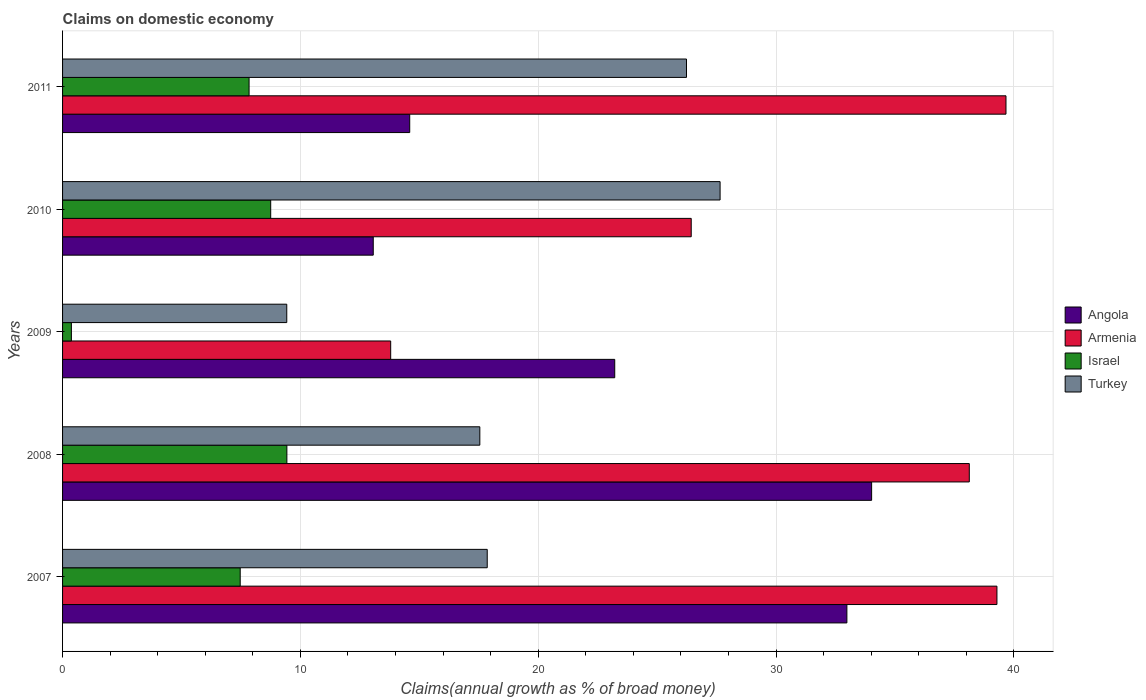How many different coloured bars are there?
Keep it short and to the point. 4. How many groups of bars are there?
Keep it short and to the point. 5. Are the number of bars per tick equal to the number of legend labels?
Your response must be concise. Yes. How many bars are there on the 2nd tick from the top?
Your response must be concise. 4. How many bars are there on the 3rd tick from the bottom?
Provide a short and direct response. 4. What is the label of the 5th group of bars from the top?
Your answer should be very brief. 2007. In how many cases, is the number of bars for a given year not equal to the number of legend labels?
Keep it short and to the point. 0. What is the percentage of broad money claimed on domestic economy in Israel in 2011?
Ensure brevity in your answer.  7.84. Across all years, what is the maximum percentage of broad money claimed on domestic economy in Turkey?
Give a very brief answer. 27.65. Across all years, what is the minimum percentage of broad money claimed on domestic economy in Israel?
Your response must be concise. 0.37. In which year was the percentage of broad money claimed on domestic economy in Angola minimum?
Give a very brief answer. 2010. What is the total percentage of broad money claimed on domestic economy in Armenia in the graph?
Provide a succinct answer. 157.31. What is the difference between the percentage of broad money claimed on domestic economy in Angola in 2007 and that in 2009?
Your answer should be very brief. 9.76. What is the difference between the percentage of broad money claimed on domestic economy in Armenia in 2009 and the percentage of broad money claimed on domestic economy in Israel in 2008?
Your answer should be very brief. 4.37. What is the average percentage of broad money claimed on domestic economy in Angola per year?
Provide a succinct answer. 23.57. In the year 2009, what is the difference between the percentage of broad money claimed on domestic economy in Angola and percentage of broad money claimed on domestic economy in Israel?
Your response must be concise. 22.85. In how many years, is the percentage of broad money claimed on domestic economy in Armenia greater than 38 %?
Your answer should be very brief. 3. What is the ratio of the percentage of broad money claimed on domestic economy in Israel in 2009 to that in 2010?
Provide a short and direct response. 0.04. Is the difference between the percentage of broad money claimed on domestic economy in Angola in 2007 and 2008 greater than the difference between the percentage of broad money claimed on domestic economy in Israel in 2007 and 2008?
Give a very brief answer. Yes. What is the difference between the highest and the second highest percentage of broad money claimed on domestic economy in Turkey?
Your response must be concise. 1.41. What is the difference between the highest and the lowest percentage of broad money claimed on domestic economy in Turkey?
Offer a very short reply. 18.22. Is the sum of the percentage of broad money claimed on domestic economy in Turkey in 2007 and 2008 greater than the maximum percentage of broad money claimed on domestic economy in Armenia across all years?
Give a very brief answer. No. Is it the case that in every year, the sum of the percentage of broad money claimed on domestic economy in Israel and percentage of broad money claimed on domestic economy in Angola is greater than the sum of percentage of broad money claimed on domestic economy in Turkey and percentage of broad money claimed on domestic economy in Armenia?
Offer a terse response. Yes. What does the 4th bar from the top in 2011 represents?
Provide a short and direct response. Angola. What does the 3rd bar from the bottom in 2011 represents?
Give a very brief answer. Israel. Is it the case that in every year, the sum of the percentage of broad money claimed on domestic economy in Turkey and percentage of broad money claimed on domestic economy in Israel is greater than the percentage of broad money claimed on domestic economy in Armenia?
Offer a very short reply. No. How many years are there in the graph?
Ensure brevity in your answer.  5. What is the difference between two consecutive major ticks on the X-axis?
Provide a short and direct response. 10. Does the graph contain grids?
Provide a succinct answer. Yes. What is the title of the graph?
Your response must be concise. Claims on domestic economy. What is the label or title of the X-axis?
Make the answer very short. Claims(annual growth as % of broad money). What is the Claims(annual growth as % of broad money) in Angola in 2007?
Give a very brief answer. 32.98. What is the Claims(annual growth as % of broad money) in Armenia in 2007?
Your answer should be very brief. 39.29. What is the Claims(annual growth as % of broad money) of Israel in 2007?
Provide a succinct answer. 7.47. What is the Claims(annual growth as % of broad money) in Turkey in 2007?
Keep it short and to the point. 17.86. What is the Claims(annual growth as % of broad money) of Angola in 2008?
Your response must be concise. 34.02. What is the Claims(annual growth as % of broad money) in Armenia in 2008?
Offer a terse response. 38.12. What is the Claims(annual growth as % of broad money) of Israel in 2008?
Make the answer very short. 9.43. What is the Claims(annual growth as % of broad money) of Turkey in 2008?
Offer a very short reply. 17.54. What is the Claims(annual growth as % of broad money) in Angola in 2009?
Your response must be concise. 23.22. What is the Claims(annual growth as % of broad money) of Armenia in 2009?
Offer a terse response. 13.8. What is the Claims(annual growth as % of broad money) in Israel in 2009?
Give a very brief answer. 0.37. What is the Claims(annual growth as % of broad money) of Turkey in 2009?
Provide a short and direct response. 9.43. What is the Claims(annual growth as % of broad money) in Angola in 2010?
Provide a succinct answer. 13.06. What is the Claims(annual growth as % of broad money) of Armenia in 2010?
Your answer should be compact. 26.43. What is the Claims(annual growth as % of broad money) of Israel in 2010?
Offer a terse response. 8.75. What is the Claims(annual growth as % of broad money) in Turkey in 2010?
Ensure brevity in your answer.  27.65. What is the Claims(annual growth as % of broad money) of Angola in 2011?
Give a very brief answer. 14.6. What is the Claims(annual growth as % of broad money) of Armenia in 2011?
Offer a terse response. 39.67. What is the Claims(annual growth as % of broad money) of Israel in 2011?
Make the answer very short. 7.84. What is the Claims(annual growth as % of broad money) in Turkey in 2011?
Offer a terse response. 26.23. Across all years, what is the maximum Claims(annual growth as % of broad money) of Angola?
Provide a short and direct response. 34.02. Across all years, what is the maximum Claims(annual growth as % of broad money) in Armenia?
Your answer should be very brief. 39.67. Across all years, what is the maximum Claims(annual growth as % of broad money) of Israel?
Offer a very short reply. 9.43. Across all years, what is the maximum Claims(annual growth as % of broad money) in Turkey?
Your response must be concise. 27.65. Across all years, what is the minimum Claims(annual growth as % of broad money) of Angola?
Give a very brief answer. 13.06. Across all years, what is the minimum Claims(annual growth as % of broad money) in Armenia?
Provide a short and direct response. 13.8. Across all years, what is the minimum Claims(annual growth as % of broad money) in Israel?
Your answer should be compact. 0.37. Across all years, what is the minimum Claims(annual growth as % of broad money) of Turkey?
Offer a terse response. 9.43. What is the total Claims(annual growth as % of broad money) in Angola in the graph?
Provide a succinct answer. 117.87. What is the total Claims(annual growth as % of broad money) in Armenia in the graph?
Offer a very short reply. 157.31. What is the total Claims(annual growth as % of broad money) of Israel in the graph?
Your answer should be very brief. 33.86. What is the total Claims(annual growth as % of broad money) in Turkey in the graph?
Give a very brief answer. 98.71. What is the difference between the Claims(annual growth as % of broad money) of Angola in 2007 and that in 2008?
Ensure brevity in your answer.  -1.04. What is the difference between the Claims(annual growth as % of broad money) of Armenia in 2007 and that in 2008?
Provide a short and direct response. 1.16. What is the difference between the Claims(annual growth as % of broad money) of Israel in 2007 and that in 2008?
Offer a very short reply. -1.96. What is the difference between the Claims(annual growth as % of broad money) in Turkey in 2007 and that in 2008?
Keep it short and to the point. 0.31. What is the difference between the Claims(annual growth as % of broad money) in Angola in 2007 and that in 2009?
Offer a very short reply. 9.76. What is the difference between the Claims(annual growth as % of broad money) in Armenia in 2007 and that in 2009?
Give a very brief answer. 25.49. What is the difference between the Claims(annual growth as % of broad money) in Israel in 2007 and that in 2009?
Give a very brief answer. 7.1. What is the difference between the Claims(annual growth as % of broad money) in Turkey in 2007 and that in 2009?
Make the answer very short. 8.43. What is the difference between the Claims(annual growth as % of broad money) in Angola in 2007 and that in 2010?
Give a very brief answer. 19.91. What is the difference between the Claims(annual growth as % of broad money) in Armenia in 2007 and that in 2010?
Ensure brevity in your answer.  12.85. What is the difference between the Claims(annual growth as % of broad money) of Israel in 2007 and that in 2010?
Provide a succinct answer. -1.28. What is the difference between the Claims(annual growth as % of broad money) of Turkey in 2007 and that in 2010?
Make the answer very short. -9.79. What is the difference between the Claims(annual growth as % of broad money) of Angola in 2007 and that in 2011?
Provide a succinct answer. 18.38. What is the difference between the Claims(annual growth as % of broad money) in Armenia in 2007 and that in 2011?
Provide a succinct answer. -0.38. What is the difference between the Claims(annual growth as % of broad money) of Israel in 2007 and that in 2011?
Make the answer very short. -0.37. What is the difference between the Claims(annual growth as % of broad money) in Turkey in 2007 and that in 2011?
Provide a short and direct response. -8.38. What is the difference between the Claims(annual growth as % of broad money) of Angola in 2008 and that in 2009?
Your answer should be compact. 10.8. What is the difference between the Claims(annual growth as % of broad money) of Armenia in 2008 and that in 2009?
Your answer should be compact. 24.33. What is the difference between the Claims(annual growth as % of broad money) in Israel in 2008 and that in 2009?
Provide a succinct answer. 9.06. What is the difference between the Claims(annual growth as % of broad money) in Turkey in 2008 and that in 2009?
Make the answer very short. 8.12. What is the difference between the Claims(annual growth as % of broad money) in Angola in 2008 and that in 2010?
Provide a succinct answer. 20.95. What is the difference between the Claims(annual growth as % of broad money) in Armenia in 2008 and that in 2010?
Offer a very short reply. 11.69. What is the difference between the Claims(annual growth as % of broad money) in Israel in 2008 and that in 2010?
Your response must be concise. 0.68. What is the difference between the Claims(annual growth as % of broad money) in Turkey in 2008 and that in 2010?
Keep it short and to the point. -10.1. What is the difference between the Claims(annual growth as % of broad money) of Angola in 2008 and that in 2011?
Offer a very short reply. 19.42. What is the difference between the Claims(annual growth as % of broad money) in Armenia in 2008 and that in 2011?
Your answer should be very brief. -1.54. What is the difference between the Claims(annual growth as % of broad money) in Israel in 2008 and that in 2011?
Give a very brief answer. 1.59. What is the difference between the Claims(annual growth as % of broad money) in Turkey in 2008 and that in 2011?
Your answer should be compact. -8.69. What is the difference between the Claims(annual growth as % of broad money) in Angola in 2009 and that in 2010?
Your response must be concise. 10.15. What is the difference between the Claims(annual growth as % of broad money) in Armenia in 2009 and that in 2010?
Keep it short and to the point. -12.64. What is the difference between the Claims(annual growth as % of broad money) in Israel in 2009 and that in 2010?
Make the answer very short. -8.38. What is the difference between the Claims(annual growth as % of broad money) in Turkey in 2009 and that in 2010?
Provide a short and direct response. -18.22. What is the difference between the Claims(annual growth as % of broad money) of Angola in 2009 and that in 2011?
Offer a terse response. 8.62. What is the difference between the Claims(annual growth as % of broad money) of Armenia in 2009 and that in 2011?
Your answer should be compact. -25.87. What is the difference between the Claims(annual growth as % of broad money) of Israel in 2009 and that in 2011?
Your response must be concise. -7.47. What is the difference between the Claims(annual growth as % of broad money) in Turkey in 2009 and that in 2011?
Give a very brief answer. -16.81. What is the difference between the Claims(annual growth as % of broad money) of Angola in 2010 and that in 2011?
Offer a terse response. -1.53. What is the difference between the Claims(annual growth as % of broad money) in Armenia in 2010 and that in 2011?
Provide a short and direct response. -13.23. What is the difference between the Claims(annual growth as % of broad money) of Israel in 2010 and that in 2011?
Give a very brief answer. 0.91. What is the difference between the Claims(annual growth as % of broad money) in Turkey in 2010 and that in 2011?
Your response must be concise. 1.41. What is the difference between the Claims(annual growth as % of broad money) of Angola in 2007 and the Claims(annual growth as % of broad money) of Armenia in 2008?
Keep it short and to the point. -5.15. What is the difference between the Claims(annual growth as % of broad money) in Angola in 2007 and the Claims(annual growth as % of broad money) in Israel in 2008?
Offer a very short reply. 23.55. What is the difference between the Claims(annual growth as % of broad money) in Angola in 2007 and the Claims(annual growth as % of broad money) in Turkey in 2008?
Provide a succinct answer. 15.43. What is the difference between the Claims(annual growth as % of broad money) in Armenia in 2007 and the Claims(annual growth as % of broad money) in Israel in 2008?
Make the answer very short. 29.86. What is the difference between the Claims(annual growth as % of broad money) in Armenia in 2007 and the Claims(annual growth as % of broad money) in Turkey in 2008?
Your response must be concise. 21.74. What is the difference between the Claims(annual growth as % of broad money) in Israel in 2007 and the Claims(annual growth as % of broad money) in Turkey in 2008?
Offer a very short reply. -10.08. What is the difference between the Claims(annual growth as % of broad money) in Angola in 2007 and the Claims(annual growth as % of broad money) in Armenia in 2009?
Keep it short and to the point. 19.18. What is the difference between the Claims(annual growth as % of broad money) in Angola in 2007 and the Claims(annual growth as % of broad money) in Israel in 2009?
Give a very brief answer. 32.61. What is the difference between the Claims(annual growth as % of broad money) in Angola in 2007 and the Claims(annual growth as % of broad money) in Turkey in 2009?
Give a very brief answer. 23.55. What is the difference between the Claims(annual growth as % of broad money) in Armenia in 2007 and the Claims(annual growth as % of broad money) in Israel in 2009?
Your answer should be compact. 38.92. What is the difference between the Claims(annual growth as % of broad money) of Armenia in 2007 and the Claims(annual growth as % of broad money) of Turkey in 2009?
Offer a terse response. 29.86. What is the difference between the Claims(annual growth as % of broad money) in Israel in 2007 and the Claims(annual growth as % of broad money) in Turkey in 2009?
Keep it short and to the point. -1.96. What is the difference between the Claims(annual growth as % of broad money) in Angola in 2007 and the Claims(annual growth as % of broad money) in Armenia in 2010?
Your answer should be compact. 6.55. What is the difference between the Claims(annual growth as % of broad money) in Angola in 2007 and the Claims(annual growth as % of broad money) in Israel in 2010?
Your response must be concise. 24.23. What is the difference between the Claims(annual growth as % of broad money) in Angola in 2007 and the Claims(annual growth as % of broad money) in Turkey in 2010?
Keep it short and to the point. 5.33. What is the difference between the Claims(annual growth as % of broad money) of Armenia in 2007 and the Claims(annual growth as % of broad money) of Israel in 2010?
Give a very brief answer. 30.54. What is the difference between the Claims(annual growth as % of broad money) of Armenia in 2007 and the Claims(annual growth as % of broad money) of Turkey in 2010?
Offer a very short reply. 11.64. What is the difference between the Claims(annual growth as % of broad money) of Israel in 2007 and the Claims(annual growth as % of broad money) of Turkey in 2010?
Give a very brief answer. -20.18. What is the difference between the Claims(annual growth as % of broad money) in Angola in 2007 and the Claims(annual growth as % of broad money) in Armenia in 2011?
Offer a very short reply. -6.69. What is the difference between the Claims(annual growth as % of broad money) in Angola in 2007 and the Claims(annual growth as % of broad money) in Israel in 2011?
Your answer should be compact. 25.14. What is the difference between the Claims(annual growth as % of broad money) of Angola in 2007 and the Claims(annual growth as % of broad money) of Turkey in 2011?
Provide a short and direct response. 6.74. What is the difference between the Claims(annual growth as % of broad money) of Armenia in 2007 and the Claims(annual growth as % of broad money) of Israel in 2011?
Offer a terse response. 31.45. What is the difference between the Claims(annual growth as % of broad money) in Armenia in 2007 and the Claims(annual growth as % of broad money) in Turkey in 2011?
Provide a succinct answer. 13.05. What is the difference between the Claims(annual growth as % of broad money) in Israel in 2007 and the Claims(annual growth as % of broad money) in Turkey in 2011?
Offer a terse response. -18.77. What is the difference between the Claims(annual growth as % of broad money) of Angola in 2008 and the Claims(annual growth as % of broad money) of Armenia in 2009?
Give a very brief answer. 20.22. What is the difference between the Claims(annual growth as % of broad money) of Angola in 2008 and the Claims(annual growth as % of broad money) of Israel in 2009?
Provide a short and direct response. 33.65. What is the difference between the Claims(annual growth as % of broad money) of Angola in 2008 and the Claims(annual growth as % of broad money) of Turkey in 2009?
Keep it short and to the point. 24.59. What is the difference between the Claims(annual growth as % of broad money) of Armenia in 2008 and the Claims(annual growth as % of broad money) of Israel in 2009?
Your answer should be compact. 37.75. What is the difference between the Claims(annual growth as % of broad money) of Armenia in 2008 and the Claims(annual growth as % of broad money) of Turkey in 2009?
Offer a very short reply. 28.7. What is the difference between the Claims(annual growth as % of broad money) of Israel in 2008 and the Claims(annual growth as % of broad money) of Turkey in 2009?
Keep it short and to the point. 0. What is the difference between the Claims(annual growth as % of broad money) of Angola in 2008 and the Claims(annual growth as % of broad money) of Armenia in 2010?
Offer a terse response. 7.58. What is the difference between the Claims(annual growth as % of broad money) of Angola in 2008 and the Claims(annual growth as % of broad money) of Israel in 2010?
Keep it short and to the point. 25.27. What is the difference between the Claims(annual growth as % of broad money) in Angola in 2008 and the Claims(annual growth as % of broad money) in Turkey in 2010?
Offer a terse response. 6.37. What is the difference between the Claims(annual growth as % of broad money) in Armenia in 2008 and the Claims(annual growth as % of broad money) in Israel in 2010?
Offer a very short reply. 29.37. What is the difference between the Claims(annual growth as % of broad money) of Armenia in 2008 and the Claims(annual growth as % of broad money) of Turkey in 2010?
Provide a short and direct response. 10.48. What is the difference between the Claims(annual growth as % of broad money) of Israel in 2008 and the Claims(annual growth as % of broad money) of Turkey in 2010?
Ensure brevity in your answer.  -18.22. What is the difference between the Claims(annual growth as % of broad money) of Angola in 2008 and the Claims(annual growth as % of broad money) of Armenia in 2011?
Provide a succinct answer. -5.65. What is the difference between the Claims(annual growth as % of broad money) of Angola in 2008 and the Claims(annual growth as % of broad money) of Israel in 2011?
Keep it short and to the point. 26.18. What is the difference between the Claims(annual growth as % of broad money) in Angola in 2008 and the Claims(annual growth as % of broad money) in Turkey in 2011?
Keep it short and to the point. 7.78. What is the difference between the Claims(annual growth as % of broad money) in Armenia in 2008 and the Claims(annual growth as % of broad money) in Israel in 2011?
Offer a very short reply. 30.28. What is the difference between the Claims(annual growth as % of broad money) in Armenia in 2008 and the Claims(annual growth as % of broad money) in Turkey in 2011?
Offer a terse response. 11.89. What is the difference between the Claims(annual growth as % of broad money) in Israel in 2008 and the Claims(annual growth as % of broad money) in Turkey in 2011?
Ensure brevity in your answer.  -16.8. What is the difference between the Claims(annual growth as % of broad money) in Angola in 2009 and the Claims(annual growth as % of broad money) in Armenia in 2010?
Keep it short and to the point. -3.22. What is the difference between the Claims(annual growth as % of broad money) of Angola in 2009 and the Claims(annual growth as % of broad money) of Israel in 2010?
Offer a very short reply. 14.47. What is the difference between the Claims(annual growth as % of broad money) of Angola in 2009 and the Claims(annual growth as % of broad money) of Turkey in 2010?
Ensure brevity in your answer.  -4.43. What is the difference between the Claims(annual growth as % of broad money) in Armenia in 2009 and the Claims(annual growth as % of broad money) in Israel in 2010?
Ensure brevity in your answer.  5.05. What is the difference between the Claims(annual growth as % of broad money) in Armenia in 2009 and the Claims(annual growth as % of broad money) in Turkey in 2010?
Offer a very short reply. -13.85. What is the difference between the Claims(annual growth as % of broad money) of Israel in 2009 and the Claims(annual growth as % of broad money) of Turkey in 2010?
Your answer should be very brief. -27.28. What is the difference between the Claims(annual growth as % of broad money) in Angola in 2009 and the Claims(annual growth as % of broad money) in Armenia in 2011?
Keep it short and to the point. -16.45. What is the difference between the Claims(annual growth as % of broad money) in Angola in 2009 and the Claims(annual growth as % of broad money) in Israel in 2011?
Give a very brief answer. 15.37. What is the difference between the Claims(annual growth as % of broad money) in Angola in 2009 and the Claims(annual growth as % of broad money) in Turkey in 2011?
Offer a terse response. -3.02. What is the difference between the Claims(annual growth as % of broad money) in Armenia in 2009 and the Claims(annual growth as % of broad money) in Israel in 2011?
Keep it short and to the point. 5.95. What is the difference between the Claims(annual growth as % of broad money) in Armenia in 2009 and the Claims(annual growth as % of broad money) in Turkey in 2011?
Your answer should be very brief. -12.44. What is the difference between the Claims(annual growth as % of broad money) in Israel in 2009 and the Claims(annual growth as % of broad money) in Turkey in 2011?
Offer a terse response. -25.86. What is the difference between the Claims(annual growth as % of broad money) of Angola in 2010 and the Claims(annual growth as % of broad money) of Armenia in 2011?
Ensure brevity in your answer.  -26.6. What is the difference between the Claims(annual growth as % of broad money) of Angola in 2010 and the Claims(annual growth as % of broad money) of Israel in 2011?
Keep it short and to the point. 5.22. What is the difference between the Claims(annual growth as % of broad money) in Angola in 2010 and the Claims(annual growth as % of broad money) in Turkey in 2011?
Offer a terse response. -13.17. What is the difference between the Claims(annual growth as % of broad money) in Armenia in 2010 and the Claims(annual growth as % of broad money) in Israel in 2011?
Your answer should be compact. 18.59. What is the difference between the Claims(annual growth as % of broad money) in Armenia in 2010 and the Claims(annual growth as % of broad money) in Turkey in 2011?
Give a very brief answer. 0.2. What is the difference between the Claims(annual growth as % of broad money) of Israel in 2010 and the Claims(annual growth as % of broad money) of Turkey in 2011?
Ensure brevity in your answer.  -17.48. What is the average Claims(annual growth as % of broad money) in Angola per year?
Offer a terse response. 23.57. What is the average Claims(annual growth as % of broad money) of Armenia per year?
Ensure brevity in your answer.  31.46. What is the average Claims(annual growth as % of broad money) in Israel per year?
Provide a succinct answer. 6.77. What is the average Claims(annual growth as % of broad money) of Turkey per year?
Offer a very short reply. 19.74. In the year 2007, what is the difference between the Claims(annual growth as % of broad money) of Angola and Claims(annual growth as % of broad money) of Armenia?
Offer a very short reply. -6.31. In the year 2007, what is the difference between the Claims(annual growth as % of broad money) in Angola and Claims(annual growth as % of broad money) in Israel?
Your answer should be very brief. 25.51. In the year 2007, what is the difference between the Claims(annual growth as % of broad money) of Angola and Claims(annual growth as % of broad money) of Turkey?
Ensure brevity in your answer.  15.12. In the year 2007, what is the difference between the Claims(annual growth as % of broad money) in Armenia and Claims(annual growth as % of broad money) in Israel?
Give a very brief answer. 31.82. In the year 2007, what is the difference between the Claims(annual growth as % of broad money) in Armenia and Claims(annual growth as % of broad money) in Turkey?
Your answer should be compact. 21.43. In the year 2007, what is the difference between the Claims(annual growth as % of broad money) in Israel and Claims(annual growth as % of broad money) in Turkey?
Your answer should be very brief. -10.39. In the year 2008, what is the difference between the Claims(annual growth as % of broad money) in Angola and Claims(annual growth as % of broad money) in Armenia?
Keep it short and to the point. -4.11. In the year 2008, what is the difference between the Claims(annual growth as % of broad money) of Angola and Claims(annual growth as % of broad money) of Israel?
Provide a short and direct response. 24.59. In the year 2008, what is the difference between the Claims(annual growth as % of broad money) of Angola and Claims(annual growth as % of broad money) of Turkey?
Give a very brief answer. 16.47. In the year 2008, what is the difference between the Claims(annual growth as % of broad money) of Armenia and Claims(annual growth as % of broad money) of Israel?
Offer a terse response. 28.69. In the year 2008, what is the difference between the Claims(annual growth as % of broad money) in Armenia and Claims(annual growth as % of broad money) in Turkey?
Make the answer very short. 20.58. In the year 2008, what is the difference between the Claims(annual growth as % of broad money) of Israel and Claims(annual growth as % of broad money) of Turkey?
Make the answer very short. -8.11. In the year 2009, what is the difference between the Claims(annual growth as % of broad money) in Angola and Claims(annual growth as % of broad money) in Armenia?
Provide a succinct answer. 9.42. In the year 2009, what is the difference between the Claims(annual growth as % of broad money) of Angola and Claims(annual growth as % of broad money) of Israel?
Offer a very short reply. 22.85. In the year 2009, what is the difference between the Claims(annual growth as % of broad money) of Angola and Claims(annual growth as % of broad money) of Turkey?
Provide a succinct answer. 13.79. In the year 2009, what is the difference between the Claims(annual growth as % of broad money) in Armenia and Claims(annual growth as % of broad money) in Israel?
Offer a terse response. 13.43. In the year 2009, what is the difference between the Claims(annual growth as % of broad money) in Armenia and Claims(annual growth as % of broad money) in Turkey?
Your answer should be very brief. 4.37. In the year 2009, what is the difference between the Claims(annual growth as % of broad money) in Israel and Claims(annual growth as % of broad money) in Turkey?
Make the answer very short. -9.06. In the year 2010, what is the difference between the Claims(annual growth as % of broad money) of Angola and Claims(annual growth as % of broad money) of Armenia?
Make the answer very short. -13.37. In the year 2010, what is the difference between the Claims(annual growth as % of broad money) of Angola and Claims(annual growth as % of broad money) of Israel?
Offer a very short reply. 4.31. In the year 2010, what is the difference between the Claims(annual growth as % of broad money) of Angola and Claims(annual growth as % of broad money) of Turkey?
Keep it short and to the point. -14.58. In the year 2010, what is the difference between the Claims(annual growth as % of broad money) in Armenia and Claims(annual growth as % of broad money) in Israel?
Your answer should be compact. 17.68. In the year 2010, what is the difference between the Claims(annual growth as % of broad money) in Armenia and Claims(annual growth as % of broad money) in Turkey?
Give a very brief answer. -1.21. In the year 2010, what is the difference between the Claims(annual growth as % of broad money) in Israel and Claims(annual growth as % of broad money) in Turkey?
Make the answer very short. -18.9. In the year 2011, what is the difference between the Claims(annual growth as % of broad money) in Angola and Claims(annual growth as % of broad money) in Armenia?
Your answer should be compact. -25.07. In the year 2011, what is the difference between the Claims(annual growth as % of broad money) of Angola and Claims(annual growth as % of broad money) of Israel?
Your answer should be compact. 6.75. In the year 2011, what is the difference between the Claims(annual growth as % of broad money) in Angola and Claims(annual growth as % of broad money) in Turkey?
Make the answer very short. -11.64. In the year 2011, what is the difference between the Claims(annual growth as % of broad money) in Armenia and Claims(annual growth as % of broad money) in Israel?
Ensure brevity in your answer.  31.83. In the year 2011, what is the difference between the Claims(annual growth as % of broad money) in Armenia and Claims(annual growth as % of broad money) in Turkey?
Provide a short and direct response. 13.43. In the year 2011, what is the difference between the Claims(annual growth as % of broad money) in Israel and Claims(annual growth as % of broad money) in Turkey?
Offer a very short reply. -18.39. What is the ratio of the Claims(annual growth as % of broad money) in Angola in 2007 to that in 2008?
Offer a terse response. 0.97. What is the ratio of the Claims(annual growth as % of broad money) in Armenia in 2007 to that in 2008?
Give a very brief answer. 1.03. What is the ratio of the Claims(annual growth as % of broad money) in Israel in 2007 to that in 2008?
Your answer should be compact. 0.79. What is the ratio of the Claims(annual growth as % of broad money) in Turkey in 2007 to that in 2008?
Your response must be concise. 1.02. What is the ratio of the Claims(annual growth as % of broad money) of Angola in 2007 to that in 2009?
Keep it short and to the point. 1.42. What is the ratio of the Claims(annual growth as % of broad money) in Armenia in 2007 to that in 2009?
Ensure brevity in your answer.  2.85. What is the ratio of the Claims(annual growth as % of broad money) of Israel in 2007 to that in 2009?
Offer a terse response. 20.14. What is the ratio of the Claims(annual growth as % of broad money) of Turkey in 2007 to that in 2009?
Give a very brief answer. 1.89. What is the ratio of the Claims(annual growth as % of broad money) of Angola in 2007 to that in 2010?
Your response must be concise. 2.52. What is the ratio of the Claims(annual growth as % of broad money) in Armenia in 2007 to that in 2010?
Offer a very short reply. 1.49. What is the ratio of the Claims(annual growth as % of broad money) in Israel in 2007 to that in 2010?
Offer a terse response. 0.85. What is the ratio of the Claims(annual growth as % of broad money) of Turkey in 2007 to that in 2010?
Offer a very short reply. 0.65. What is the ratio of the Claims(annual growth as % of broad money) of Angola in 2007 to that in 2011?
Make the answer very short. 2.26. What is the ratio of the Claims(annual growth as % of broad money) of Armenia in 2007 to that in 2011?
Ensure brevity in your answer.  0.99. What is the ratio of the Claims(annual growth as % of broad money) in Turkey in 2007 to that in 2011?
Offer a terse response. 0.68. What is the ratio of the Claims(annual growth as % of broad money) of Angola in 2008 to that in 2009?
Keep it short and to the point. 1.47. What is the ratio of the Claims(annual growth as % of broad money) of Armenia in 2008 to that in 2009?
Offer a very short reply. 2.76. What is the ratio of the Claims(annual growth as % of broad money) of Israel in 2008 to that in 2009?
Your response must be concise. 25.43. What is the ratio of the Claims(annual growth as % of broad money) of Turkey in 2008 to that in 2009?
Offer a very short reply. 1.86. What is the ratio of the Claims(annual growth as % of broad money) of Angola in 2008 to that in 2010?
Offer a very short reply. 2.6. What is the ratio of the Claims(annual growth as % of broad money) of Armenia in 2008 to that in 2010?
Provide a succinct answer. 1.44. What is the ratio of the Claims(annual growth as % of broad money) of Israel in 2008 to that in 2010?
Your answer should be very brief. 1.08. What is the ratio of the Claims(annual growth as % of broad money) in Turkey in 2008 to that in 2010?
Your answer should be very brief. 0.63. What is the ratio of the Claims(annual growth as % of broad money) in Angola in 2008 to that in 2011?
Your response must be concise. 2.33. What is the ratio of the Claims(annual growth as % of broad money) of Armenia in 2008 to that in 2011?
Keep it short and to the point. 0.96. What is the ratio of the Claims(annual growth as % of broad money) of Israel in 2008 to that in 2011?
Make the answer very short. 1.2. What is the ratio of the Claims(annual growth as % of broad money) of Turkey in 2008 to that in 2011?
Your answer should be compact. 0.67. What is the ratio of the Claims(annual growth as % of broad money) in Angola in 2009 to that in 2010?
Keep it short and to the point. 1.78. What is the ratio of the Claims(annual growth as % of broad money) of Armenia in 2009 to that in 2010?
Ensure brevity in your answer.  0.52. What is the ratio of the Claims(annual growth as % of broad money) of Israel in 2009 to that in 2010?
Your answer should be compact. 0.04. What is the ratio of the Claims(annual growth as % of broad money) of Turkey in 2009 to that in 2010?
Ensure brevity in your answer.  0.34. What is the ratio of the Claims(annual growth as % of broad money) in Angola in 2009 to that in 2011?
Your answer should be very brief. 1.59. What is the ratio of the Claims(annual growth as % of broad money) in Armenia in 2009 to that in 2011?
Keep it short and to the point. 0.35. What is the ratio of the Claims(annual growth as % of broad money) of Israel in 2009 to that in 2011?
Your answer should be compact. 0.05. What is the ratio of the Claims(annual growth as % of broad money) in Turkey in 2009 to that in 2011?
Make the answer very short. 0.36. What is the ratio of the Claims(annual growth as % of broad money) in Angola in 2010 to that in 2011?
Offer a very short reply. 0.9. What is the ratio of the Claims(annual growth as % of broad money) in Armenia in 2010 to that in 2011?
Your response must be concise. 0.67. What is the ratio of the Claims(annual growth as % of broad money) in Israel in 2010 to that in 2011?
Ensure brevity in your answer.  1.12. What is the ratio of the Claims(annual growth as % of broad money) in Turkey in 2010 to that in 2011?
Offer a terse response. 1.05. What is the difference between the highest and the second highest Claims(annual growth as % of broad money) in Angola?
Keep it short and to the point. 1.04. What is the difference between the highest and the second highest Claims(annual growth as % of broad money) of Armenia?
Your response must be concise. 0.38. What is the difference between the highest and the second highest Claims(annual growth as % of broad money) in Israel?
Give a very brief answer. 0.68. What is the difference between the highest and the second highest Claims(annual growth as % of broad money) of Turkey?
Your response must be concise. 1.41. What is the difference between the highest and the lowest Claims(annual growth as % of broad money) of Angola?
Make the answer very short. 20.95. What is the difference between the highest and the lowest Claims(annual growth as % of broad money) in Armenia?
Give a very brief answer. 25.87. What is the difference between the highest and the lowest Claims(annual growth as % of broad money) of Israel?
Ensure brevity in your answer.  9.06. What is the difference between the highest and the lowest Claims(annual growth as % of broad money) in Turkey?
Offer a very short reply. 18.22. 